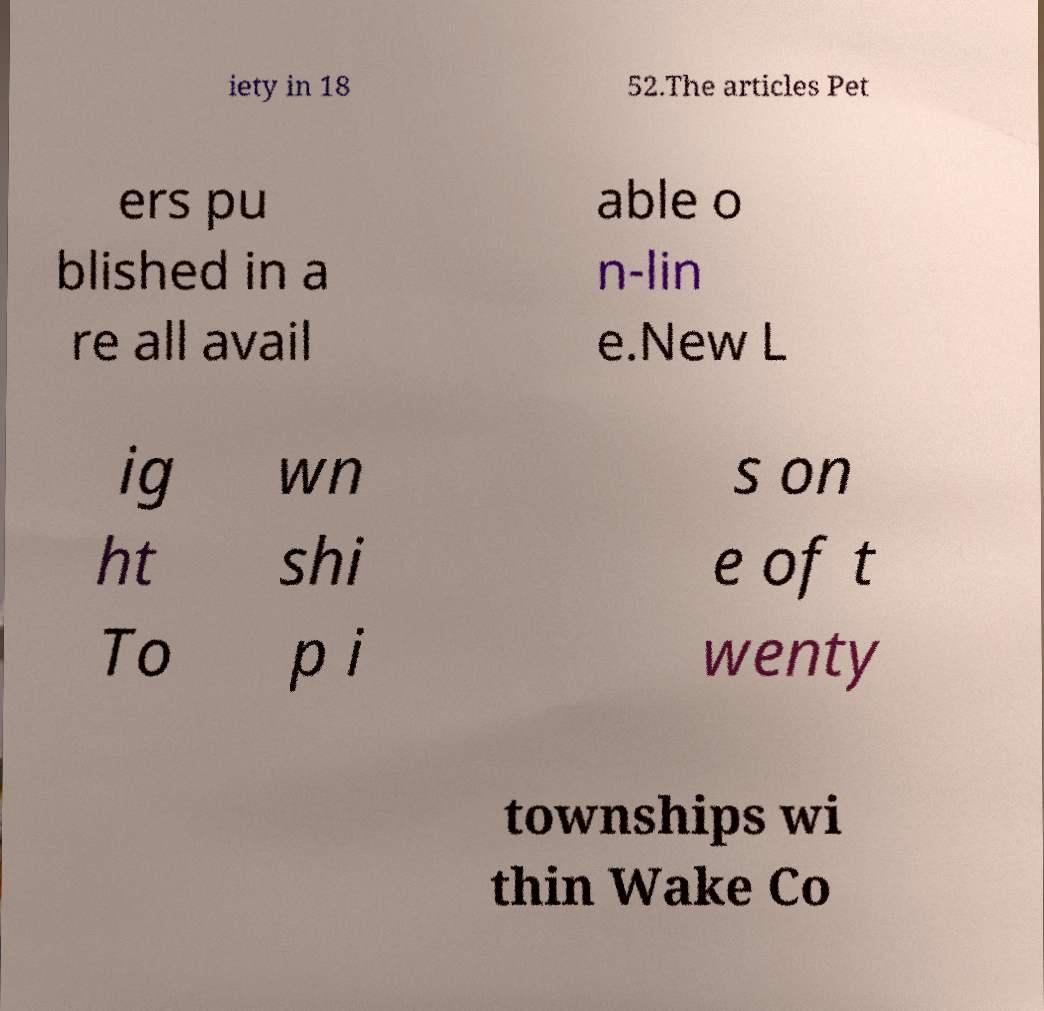There's text embedded in this image that I need extracted. Can you transcribe it verbatim? iety in 18 52.The articles Pet ers pu blished in a re all avail able o n-lin e.New L ig ht To wn shi p i s on e of t wenty townships wi thin Wake Co 